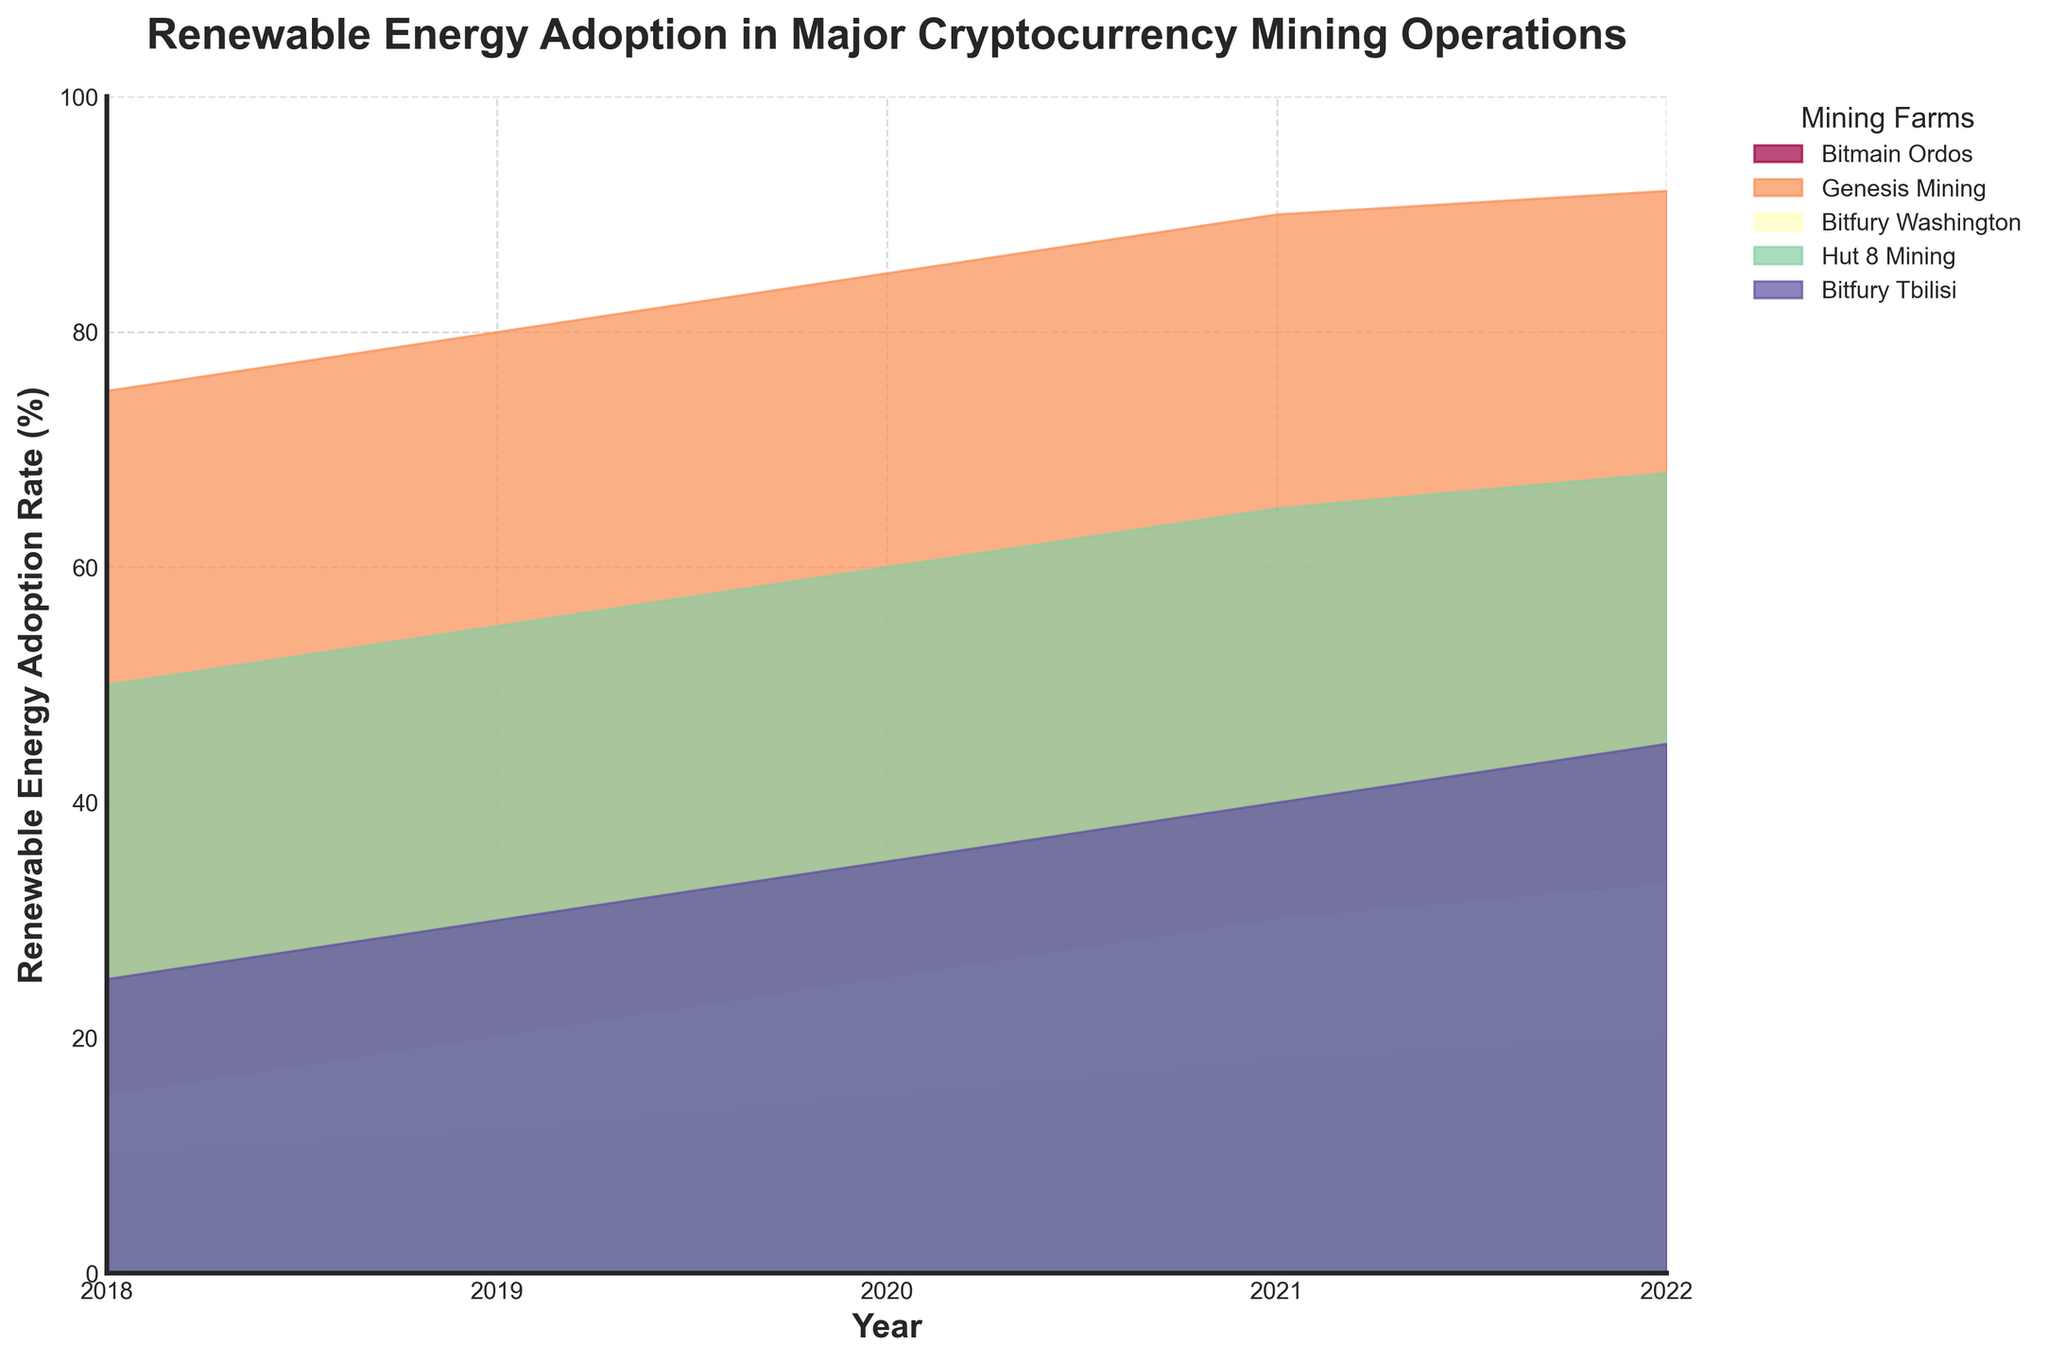Which mining farm had the highest renewable energy adoption rate in 2022? Look at the end of the figure, focusing on the height of the colored areas. Identify the mining farm corresponding to the tallest area.
Answer: Genesis Mining What is the title of the figure? The title is usually located at the top of the figure.
Answer: Renewable Energy Adoption in Major Cryptocurrency Mining Operations Across all years, which mining farm showed the most significant increase in the renewable energy adoption rate? Compare the heights of the areas representing each mining farm from the earliest year to the latest year, noting the one with the largest difference.
Answer: Genesis Mining How much did Bitfury Tbilisi's renewable energy adoption rate increase from 2018 to 2022? Subtract the 2018 value of Bitfury Tbilisi's renewable energy adoption rate from the 2022 value.
Answer: 20% Which mining farms had renewable energy adoption rates between 60% and 70% in 2021? Identify the areas whose heights fall between 60% and 70% for the year 2021.
Answer: Hut 8 Mining What is the trend of Bitmain Ordos's renewable energy adoption rate from 2018 to 2022? Follow the height of Bitmain Ordos's area across the years from left to right.
Answer: Increasing Which country had a mining farm with at least 80% renewable energy adoption in 2020? Look at the year 2020 and identify the country of the mining farm with a height of at least 80%.
Answer: Iceland Comparing 2018 and 2020, did any mining farms see a decrease in renewable energy adoption rates? For each mining farm, compare the heights of their areas for 2018 and 2020, noting any decreases.
Answer: No On average, how much did the renewable energy adoption rate for all mining farms increase from 2018 to 2022? Calculate the average increase by summing the increases of all mining farms from 2018 to 2022, then divide by the number of mining farms (5).
Answer: 7.2% In which year did Bitfury Washington have a renewable energy adoption rate of 25%? Find the year where the height of Bitfury Washington's area corresponds to 25%.
Answer: 2020 